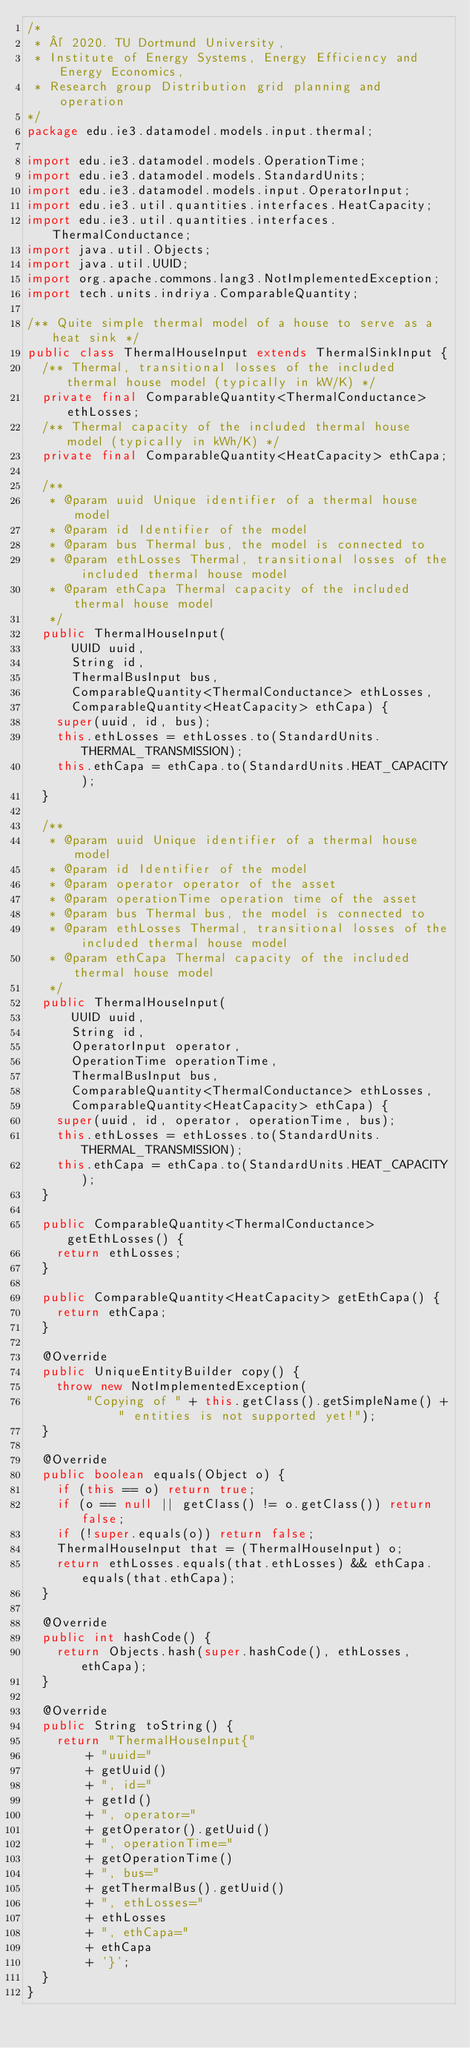Convert code to text. <code><loc_0><loc_0><loc_500><loc_500><_Java_>/*
 * © 2020. TU Dortmund University,
 * Institute of Energy Systems, Energy Efficiency and Energy Economics,
 * Research group Distribution grid planning and operation
*/
package edu.ie3.datamodel.models.input.thermal;

import edu.ie3.datamodel.models.OperationTime;
import edu.ie3.datamodel.models.StandardUnits;
import edu.ie3.datamodel.models.input.OperatorInput;
import edu.ie3.util.quantities.interfaces.HeatCapacity;
import edu.ie3.util.quantities.interfaces.ThermalConductance;
import java.util.Objects;
import java.util.UUID;
import org.apache.commons.lang3.NotImplementedException;
import tech.units.indriya.ComparableQuantity;

/** Quite simple thermal model of a house to serve as a heat sink */
public class ThermalHouseInput extends ThermalSinkInput {
  /** Thermal, transitional losses of the included thermal house model (typically in kW/K) */
  private final ComparableQuantity<ThermalConductance> ethLosses;
  /** Thermal capacity of the included thermal house model (typically in kWh/K) */
  private final ComparableQuantity<HeatCapacity> ethCapa;

  /**
   * @param uuid Unique identifier of a thermal house model
   * @param id Identifier of the model
   * @param bus Thermal bus, the model is connected to
   * @param ethLosses Thermal, transitional losses of the included thermal house model
   * @param ethCapa Thermal capacity of the included thermal house model
   */
  public ThermalHouseInput(
      UUID uuid,
      String id,
      ThermalBusInput bus,
      ComparableQuantity<ThermalConductance> ethLosses,
      ComparableQuantity<HeatCapacity> ethCapa) {
    super(uuid, id, bus);
    this.ethLosses = ethLosses.to(StandardUnits.THERMAL_TRANSMISSION);
    this.ethCapa = ethCapa.to(StandardUnits.HEAT_CAPACITY);
  }

  /**
   * @param uuid Unique identifier of a thermal house model
   * @param id Identifier of the model
   * @param operator operator of the asset
   * @param operationTime operation time of the asset
   * @param bus Thermal bus, the model is connected to
   * @param ethLosses Thermal, transitional losses of the included thermal house model
   * @param ethCapa Thermal capacity of the included thermal house model
   */
  public ThermalHouseInput(
      UUID uuid,
      String id,
      OperatorInput operator,
      OperationTime operationTime,
      ThermalBusInput bus,
      ComparableQuantity<ThermalConductance> ethLosses,
      ComparableQuantity<HeatCapacity> ethCapa) {
    super(uuid, id, operator, operationTime, bus);
    this.ethLosses = ethLosses.to(StandardUnits.THERMAL_TRANSMISSION);
    this.ethCapa = ethCapa.to(StandardUnits.HEAT_CAPACITY);
  }

  public ComparableQuantity<ThermalConductance> getEthLosses() {
    return ethLosses;
  }

  public ComparableQuantity<HeatCapacity> getEthCapa() {
    return ethCapa;
  }

  @Override
  public UniqueEntityBuilder copy() {
    throw new NotImplementedException(
        "Copying of " + this.getClass().getSimpleName() + " entities is not supported yet!");
  }

  @Override
  public boolean equals(Object o) {
    if (this == o) return true;
    if (o == null || getClass() != o.getClass()) return false;
    if (!super.equals(o)) return false;
    ThermalHouseInput that = (ThermalHouseInput) o;
    return ethLosses.equals(that.ethLosses) && ethCapa.equals(that.ethCapa);
  }

  @Override
  public int hashCode() {
    return Objects.hash(super.hashCode(), ethLosses, ethCapa);
  }

  @Override
  public String toString() {
    return "ThermalHouseInput{"
        + "uuid="
        + getUuid()
        + ", id="
        + getId()
        + ", operator="
        + getOperator().getUuid()
        + ", operationTime="
        + getOperationTime()
        + ", bus="
        + getThermalBus().getUuid()
        + ", ethLosses="
        + ethLosses
        + ", ethCapa="
        + ethCapa
        + '}';
  }
}
</code> 